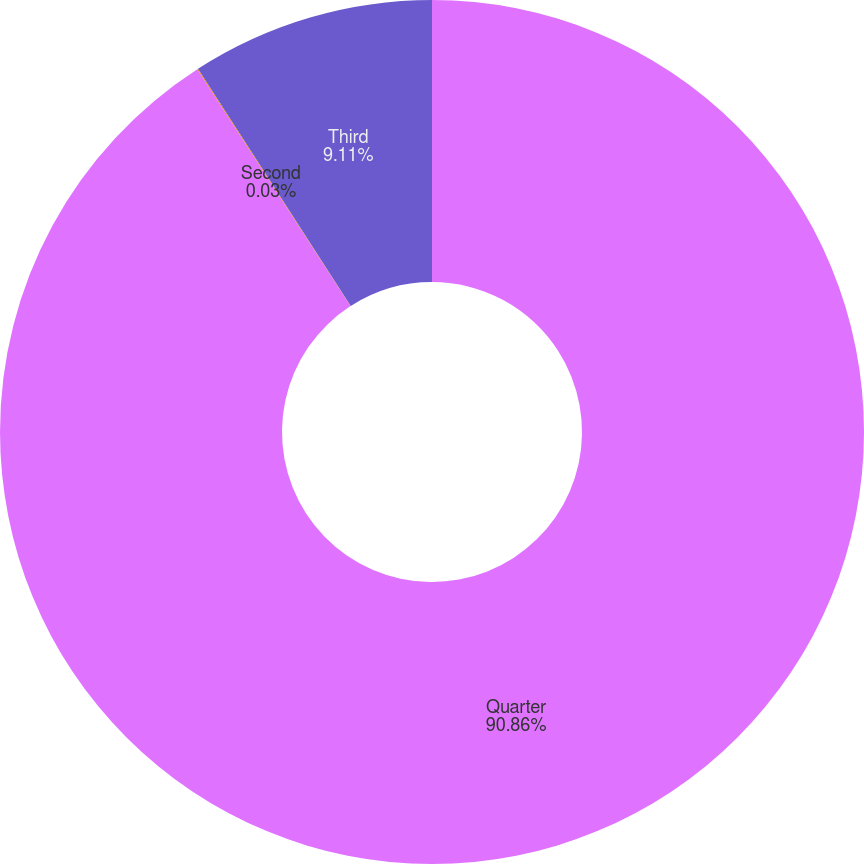Convert chart to OTSL. <chart><loc_0><loc_0><loc_500><loc_500><pie_chart><fcel>Quarter<fcel>Second<fcel>Third<nl><fcel>90.86%<fcel>0.03%<fcel>9.11%<nl></chart> 